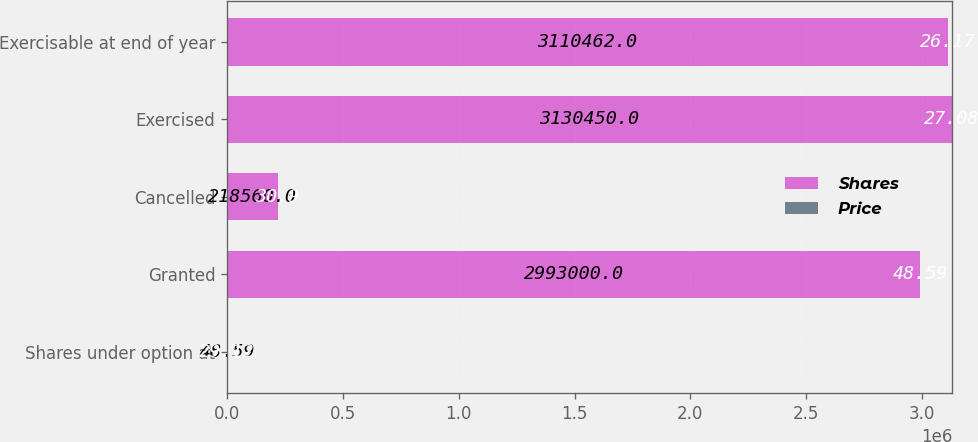<chart> <loc_0><loc_0><loc_500><loc_500><stacked_bar_chart><ecel><fcel>Shares under option at<fcel>Granted<fcel>Cancelled<fcel>Exercised<fcel>Exercisable at end of year<nl><fcel>Shares<fcel>48.59<fcel>2.993e+06<fcel>218560<fcel>3.13045e+06<fcel>3.11046e+06<nl><fcel>Price<fcel>29.12<fcel>48.59<fcel>30.9<fcel>27.08<fcel>26.17<nl></chart> 